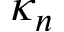Convert formula to latex. <formula><loc_0><loc_0><loc_500><loc_500>\kappa _ { n }</formula> 